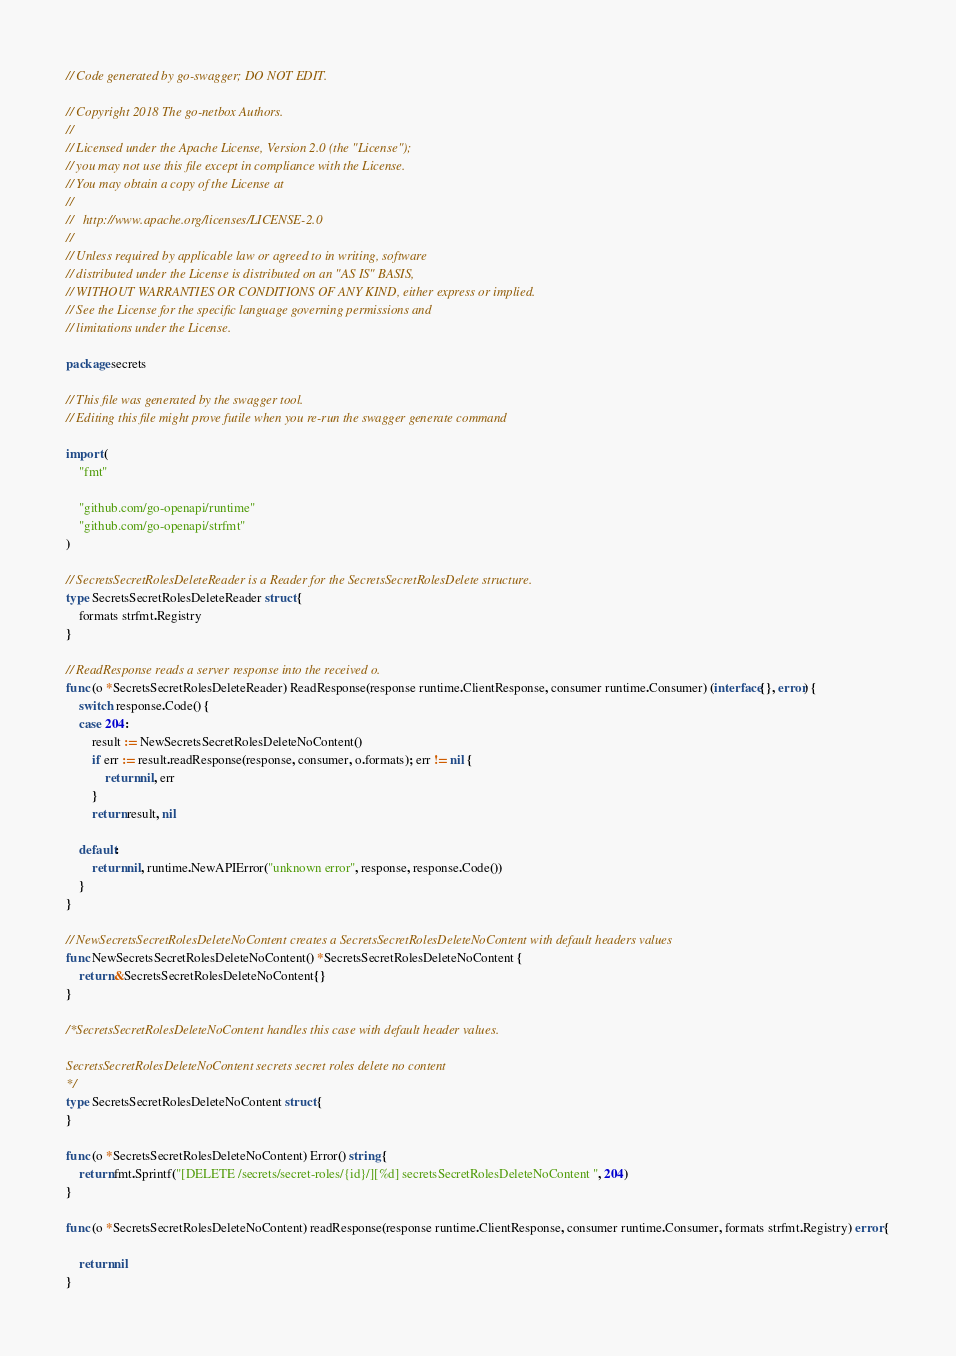Convert code to text. <code><loc_0><loc_0><loc_500><loc_500><_Go_>// Code generated by go-swagger; DO NOT EDIT.

// Copyright 2018 The go-netbox Authors.
//
// Licensed under the Apache License, Version 2.0 (the "License");
// you may not use this file except in compliance with the License.
// You may obtain a copy of the License at
//
//   http://www.apache.org/licenses/LICENSE-2.0
//
// Unless required by applicable law or agreed to in writing, software
// distributed under the License is distributed on an "AS IS" BASIS,
// WITHOUT WARRANTIES OR CONDITIONS OF ANY KIND, either express or implied.
// See the License for the specific language governing permissions and
// limitations under the License.

package secrets

// This file was generated by the swagger tool.
// Editing this file might prove futile when you re-run the swagger generate command

import (
	"fmt"

	"github.com/go-openapi/runtime"
	"github.com/go-openapi/strfmt"
)

// SecretsSecretRolesDeleteReader is a Reader for the SecretsSecretRolesDelete structure.
type SecretsSecretRolesDeleteReader struct {
	formats strfmt.Registry
}

// ReadResponse reads a server response into the received o.
func (o *SecretsSecretRolesDeleteReader) ReadResponse(response runtime.ClientResponse, consumer runtime.Consumer) (interface{}, error) {
	switch response.Code() {
	case 204:
		result := NewSecretsSecretRolesDeleteNoContent()
		if err := result.readResponse(response, consumer, o.formats); err != nil {
			return nil, err
		}
		return result, nil

	default:
		return nil, runtime.NewAPIError("unknown error", response, response.Code())
	}
}

// NewSecretsSecretRolesDeleteNoContent creates a SecretsSecretRolesDeleteNoContent with default headers values
func NewSecretsSecretRolesDeleteNoContent() *SecretsSecretRolesDeleteNoContent {
	return &SecretsSecretRolesDeleteNoContent{}
}

/*SecretsSecretRolesDeleteNoContent handles this case with default header values.

SecretsSecretRolesDeleteNoContent secrets secret roles delete no content
*/
type SecretsSecretRolesDeleteNoContent struct {
}

func (o *SecretsSecretRolesDeleteNoContent) Error() string {
	return fmt.Sprintf("[DELETE /secrets/secret-roles/{id}/][%d] secretsSecretRolesDeleteNoContent ", 204)
}

func (o *SecretsSecretRolesDeleteNoContent) readResponse(response runtime.ClientResponse, consumer runtime.Consumer, formats strfmt.Registry) error {

	return nil
}
</code> 